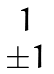Convert formula to latex. <formula><loc_0><loc_0><loc_500><loc_500>\begin{matrix} 1 \\ { \pm } 1 \end{matrix}</formula> 